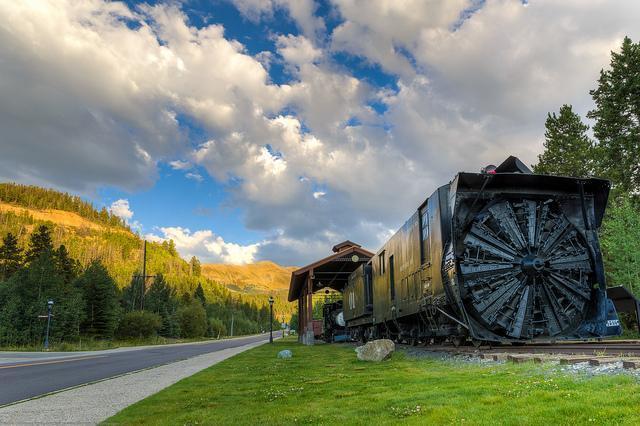How many chairs are there?
Give a very brief answer. 0. 